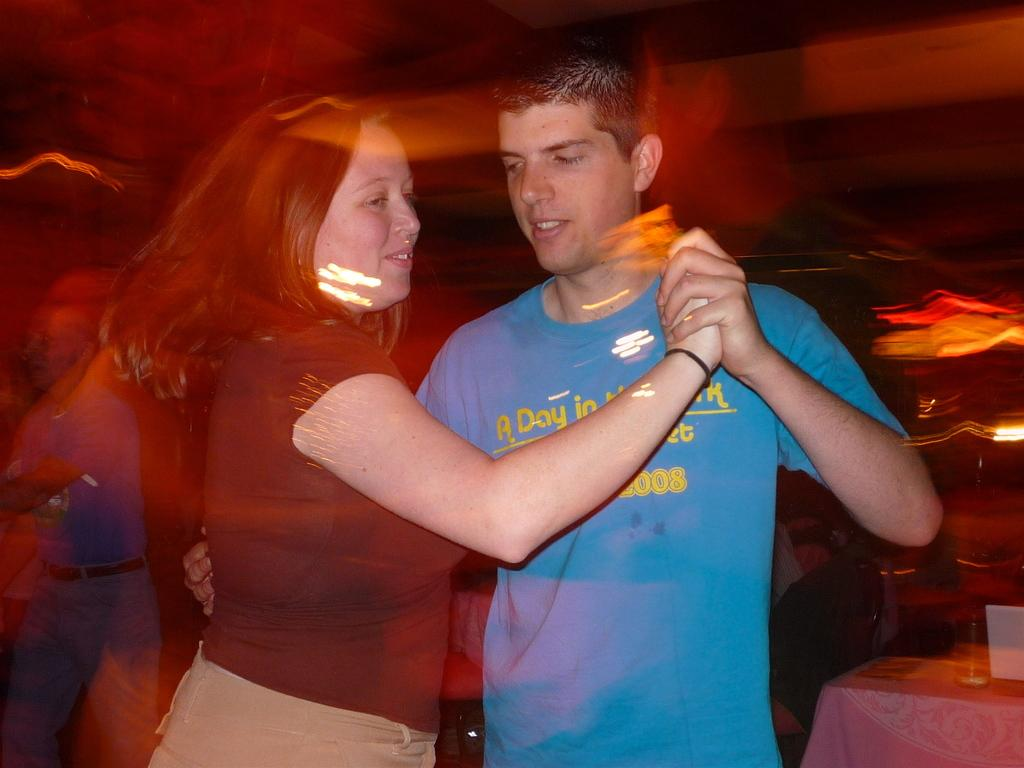What are the two people in the image doing? The two people in the image are dancing. What object can be seen on the right side of the image? There is a table on the right side of the image. How would you describe the background of the image? The background of the image is blurred. How many pigs are present on the table in the image? There are no pigs present on the table or in the image. What type of paper is being used by the dancers in the image? There is no paper visible in the image, as the focus is on the two people dancing. 